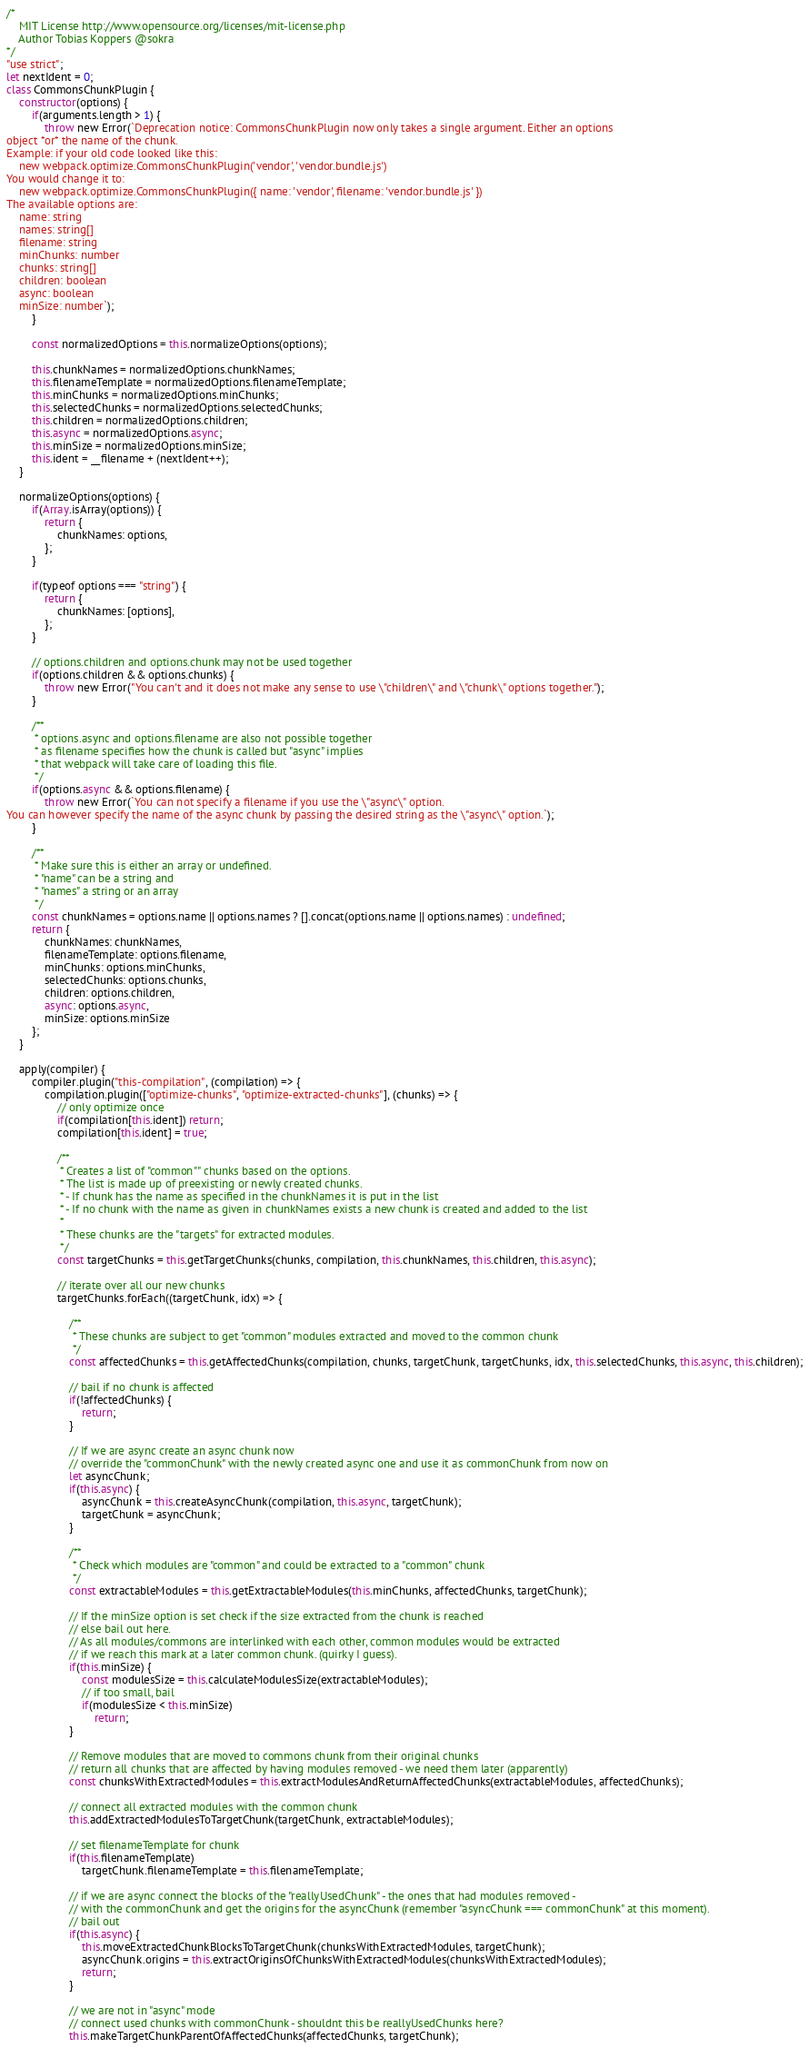<code> <loc_0><loc_0><loc_500><loc_500><_JavaScript_>/*
	MIT License http://www.opensource.org/licenses/mit-license.php
	Author Tobias Koppers @sokra
*/
"use strict";
let nextIdent = 0;
class CommonsChunkPlugin {
	constructor(options) {
		if(arguments.length > 1) {
			throw new Error(`Deprecation notice: CommonsChunkPlugin now only takes a single argument. Either an options
object *or* the name of the chunk.
Example: if your old code looked like this:
	new webpack.optimize.CommonsChunkPlugin('vendor', 'vendor.bundle.js')
You would change it to:
	new webpack.optimize.CommonsChunkPlugin({ name: 'vendor', filename: 'vendor.bundle.js' })
The available options are:
	name: string
	names: string[]
	filename: string
	minChunks: number
	chunks: string[]
	children: boolean
	async: boolean
	minSize: number`);
		}

		const normalizedOptions = this.normalizeOptions(options);

		this.chunkNames = normalizedOptions.chunkNames;
		this.filenameTemplate = normalizedOptions.filenameTemplate;
		this.minChunks = normalizedOptions.minChunks;
		this.selectedChunks = normalizedOptions.selectedChunks;
		this.children = normalizedOptions.children;
		this.async = normalizedOptions.async;
		this.minSize = normalizedOptions.minSize;
		this.ident = __filename + (nextIdent++);
	}

	normalizeOptions(options) {
		if(Array.isArray(options)) {
			return {
				chunkNames: options,
			};
		}

		if(typeof options === "string") {
			return {
				chunkNames: [options],
			};
		}

		// options.children and options.chunk may not be used together
		if(options.children && options.chunks) {
			throw new Error("You can't and it does not make any sense to use \"children\" and \"chunk\" options together.");
		}

		/**
		 * options.async and options.filename are also not possible together
		 * as filename specifies how the chunk is called but "async" implies
		 * that webpack will take care of loading this file.
		 */
		if(options.async && options.filename) {
			throw new Error(`You can not specify a filename if you use the \"async\" option.
You can however specify the name of the async chunk by passing the desired string as the \"async\" option.`);
		}

		/**
		 * Make sure this is either an array or undefined.
		 * "name" can be a string and
		 * "names" a string or an array
		 */
		const chunkNames = options.name || options.names ? [].concat(options.name || options.names) : undefined;
		return {
			chunkNames: chunkNames,
			filenameTemplate: options.filename,
			minChunks: options.minChunks,
			selectedChunks: options.chunks,
			children: options.children,
			async: options.async,
			minSize: options.minSize
		};
	}

	apply(compiler) {
		compiler.plugin("this-compilation", (compilation) => {
			compilation.plugin(["optimize-chunks", "optimize-extracted-chunks"], (chunks) => {
				// only optimize once
				if(compilation[this.ident]) return;
				compilation[this.ident] = true;

				/**
				 * Creates a list of "common"" chunks based on the options.
				 * The list is made up of preexisting or newly created chunks.
				 * - If chunk has the name as specified in the chunkNames it is put in the list
				 * - If no chunk with the name as given in chunkNames exists a new chunk is created and added to the list
				 *
				 * These chunks are the "targets" for extracted modules.
				 */
				const targetChunks = this.getTargetChunks(chunks, compilation, this.chunkNames, this.children, this.async);

				// iterate over all our new chunks
				targetChunks.forEach((targetChunk, idx) => {

					/**
					 * These chunks are subject to get "common" modules extracted and moved to the common chunk
					 */
					const affectedChunks = this.getAffectedChunks(compilation, chunks, targetChunk, targetChunks, idx, this.selectedChunks, this.async, this.children);

					// bail if no chunk is affected
					if(!affectedChunks) {
						return;
					}

					// If we are async create an async chunk now
					// override the "commonChunk" with the newly created async one and use it as commonChunk from now on
					let asyncChunk;
					if(this.async) {
						asyncChunk = this.createAsyncChunk(compilation, this.async, targetChunk);
						targetChunk = asyncChunk;
					}

					/**
					 * Check which modules are "common" and could be extracted to a "common" chunk
					 */
					const extractableModules = this.getExtractableModules(this.minChunks, affectedChunks, targetChunk);

					// If the minSize option is set check if the size extracted from the chunk is reached
					// else bail out here.
					// As all modules/commons are interlinked with each other, common modules would be extracted
					// if we reach this mark at a later common chunk. (quirky I guess).
					if(this.minSize) {
						const modulesSize = this.calculateModulesSize(extractableModules);
						// if too small, bail
						if(modulesSize < this.minSize)
							return;
					}

					// Remove modules that are moved to commons chunk from their original chunks
					// return all chunks that are affected by having modules removed - we need them later (apparently)
					const chunksWithExtractedModules = this.extractModulesAndReturnAffectedChunks(extractableModules, affectedChunks);

					// connect all extracted modules with the common chunk
					this.addExtractedModulesToTargetChunk(targetChunk, extractableModules);

					// set filenameTemplate for chunk
					if(this.filenameTemplate)
						targetChunk.filenameTemplate = this.filenameTemplate;

					// if we are async connect the blocks of the "reallyUsedChunk" - the ones that had modules removed -
					// with the commonChunk and get the origins for the asyncChunk (remember "asyncChunk === commonChunk" at this moment).
					// bail out
					if(this.async) {
						this.moveExtractedChunkBlocksToTargetChunk(chunksWithExtractedModules, targetChunk);
						asyncChunk.origins = this.extractOriginsOfChunksWithExtractedModules(chunksWithExtractedModules);
						return;
					}

					// we are not in "async" mode
					// connect used chunks with commonChunk - shouldnt this be reallyUsedChunks here?
					this.makeTargetChunkParentOfAffectedChunks(affectedChunks, targetChunk);</code> 